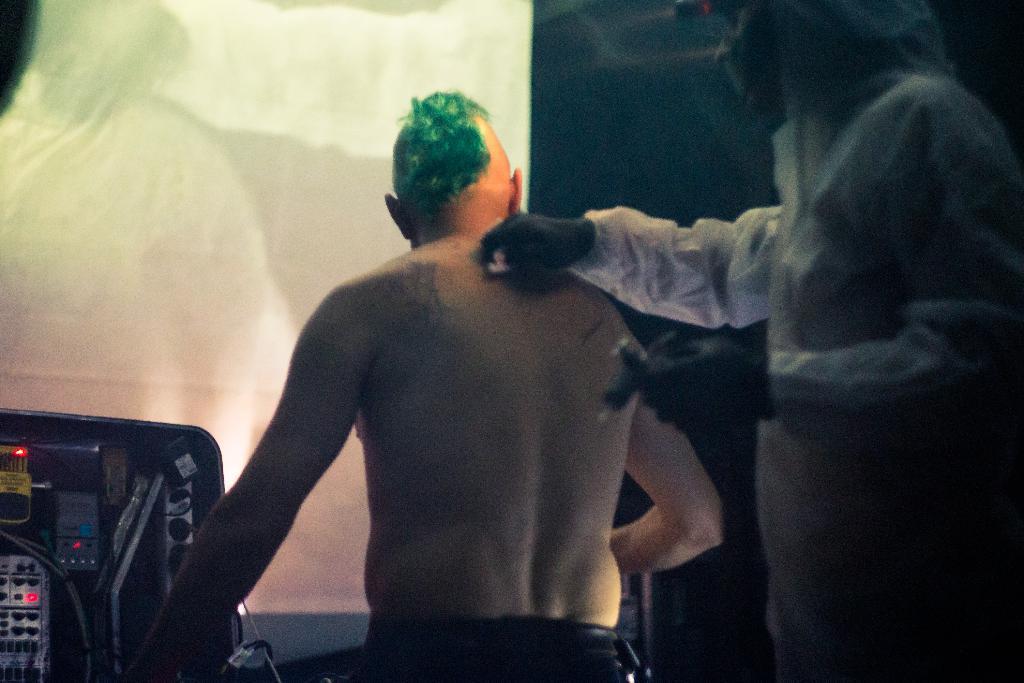Describe this image in one or two sentences. On the right there is a person. In the center of the picture there is a person sitting. On the left there is a machine. In the background there is a curtain. 